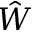Convert formula to latex. <formula><loc_0><loc_0><loc_500><loc_500>\hat { W }</formula> 